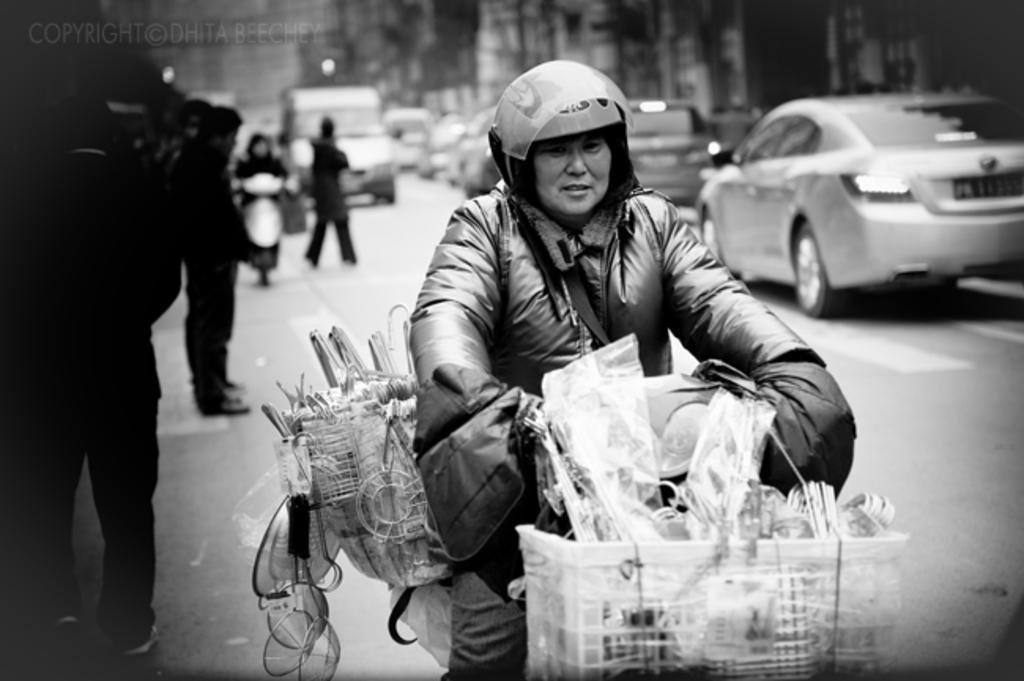In one or two sentences, can you explain what this image depicts? In this image there are group of persons, there are persons riding a vehicle, there is a vehicle truncated towards the bottom of the image, there are objects truncated towards the bottom of the image, there are vehicles on the road, there is a vehicle truncated towards the right of the image, there are buildings truncated towards the top of the image, there is text towards the top of the image. 